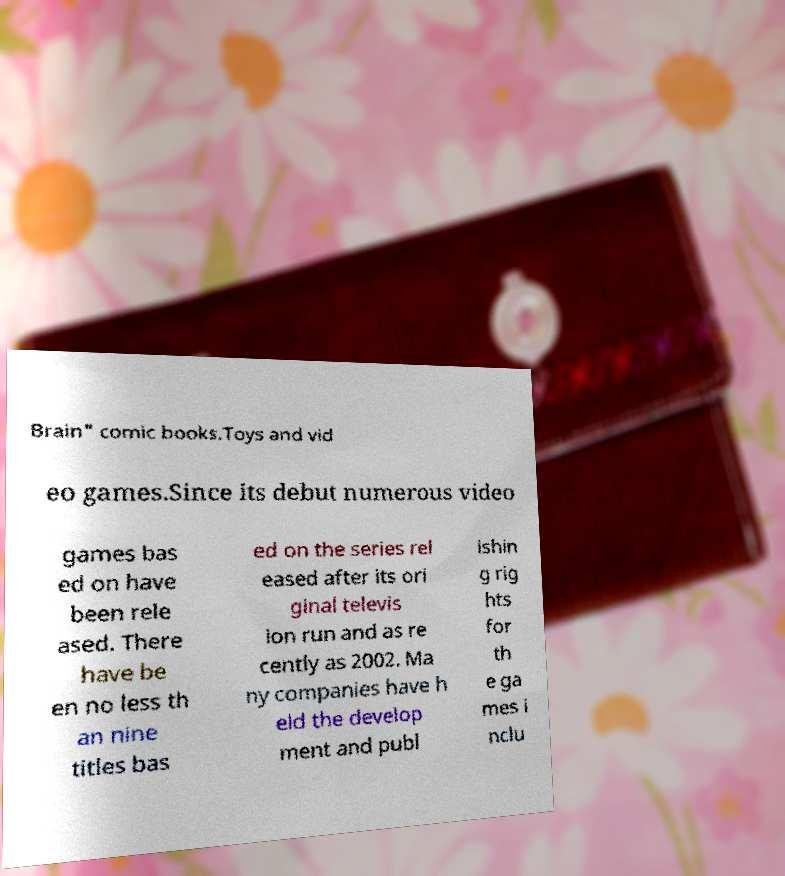Please read and relay the text visible in this image. What does it say? Brain" comic books.Toys and vid eo games.Since its debut numerous video games bas ed on have been rele ased. There have be en no less th an nine titles bas ed on the series rel eased after its ori ginal televis ion run and as re cently as 2002. Ma ny companies have h eld the develop ment and publ ishin g rig hts for th e ga mes i nclu 